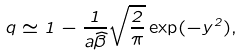Convert formula to latex. <formula><loc_0><loc_0><loc_500><loc_500>q \simeq 1 - \frac { 1 } { a \widehat { \beta } } \sqrt { \frac { 2 } { \pi } } \exp ( - y ^ { 2 } ) ,</formula> 